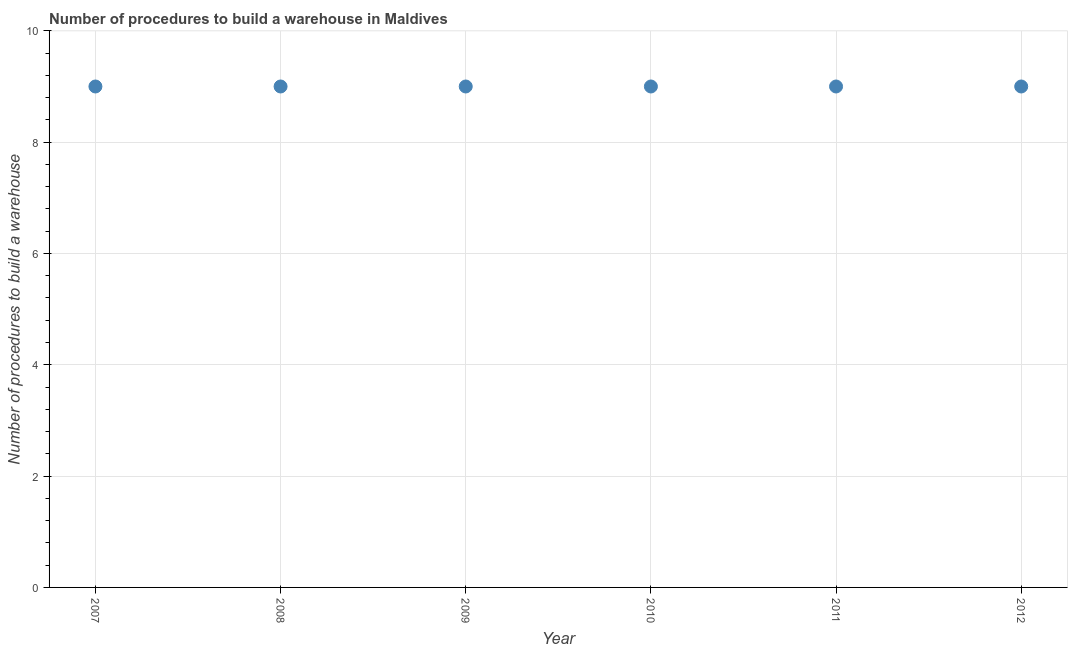What is the number of procedures to build a warehouse in 2008?
Provide a short and direct response. 9. Across all years, what is the maximum number of procedures to build a warehouse?
Offer a terse response. 9. Across all years, what is the minimum number of procedures to build a warehouse?
Your answer should be compact. 9. In which year was the number of procedures to build a warehouse maximum?
Provide a succinct answer. 2007. What is the sum of the number of procedures to build a warehouse?
Give a very brief answer. 54. What is the difference between the number of procedures to build a warehouse in 2007 and 2012?
Provide a short and direct response. 0. What is the average number of procedures to build a warehouse per year?
Offer a terse response. 9. What is the median number of procedures to build a warehouse?
Your answer should be compact. 9. In how many years, is the number of procedures to build a warehouse greater than 0.4 ?
Ensure brevity in your answer.  6. Do a majority of the years between 2010 and 2008 (inclusive) have number of procedures to build a warehouse greater than 4 ?
Make the answer very short. No. What is the ratio of the number of procedures to build a warehouse in 2007 to that in 2009?
Make the answer very short. 1. Is the number of procedures to build a warehouse in 2008 less than that in 2009?
Give a very brief answer. No. What is the difference between the highest and the second highest number of procedures to build a warehouse?
Provide a short and direct response. 0. Is the sum of the number of procedures to build a warehouse in 2007 and 2012 greater than the maximum number of procedures to build a warehouse across all years?
Offer a very short reply. Yes. What is the difference between the highest and the lowest number of procedures to build a warehouse?
Keep it short and to the point. 0. Does the number of procedures to build a warehouse monotonically increase over the years?
Keep it short and to the point. No. How many dotlines are there?
Provide a succinct answer. 1. Does the graph contain any zero values?
Offer a terse response. No. Does the graph contain grids?
Your response must be concise. Yes. What is the title of the graph?
Make the answer very short. Number of procedures to build a warehouse in Maldives. What is the label or title of the X-axis?
Keep it short and to the point. Year. What is the label or title of the Y-axis?
Your answer should be very brief. Number of procedures to build a warehouse. What is the Number of procedures to build a warehouse in 2007?
Provide a short and direct response. 9. What is the Number of procedures to build a warehouse in 2012?
Your answer should be very brief. 9. What is the difference between the Number of procedures to build a warehouse in 2007 and 2010?
Your answer should be compact. 0. What is the difference between the Number of procedures to build a warehouse in 2007 and 2011?
Provide a short and direct response. 0. What is the difference between the Number of procedures to build a warehouse in 2008 and 2009?
Your response must be concise. 0. What is the difference between the Number of procedures to build a warehouse in 2008 and 2010?
Ensure brevity in your answer.  0. What is the difference between the Number of procedures to build a warehouse in 2008 and 2011?
Ensure brevity in your answer.  0. What is the difference between the Number of procedures to build a warehouse in 2009 and 2010?
Provide a short and direct response. 0. What is the ratio of the Number of procedures to build a warehouse in 2007 to that in 2008?
Make the answer very short. 1. What is the ratio of the Number of procedures to build a warehouse in 2007 to that in 2009?
Ensure brevity in your answer.  1. What is the ratio of the Number of procedures to build a warehouse in 2007 to that in 2010?
Offer a very short reply. 1. What is the ratio of the Number of procedures to build a warehouse in 2007 to that in 2011?
Your answer should be compact. 1. What is the ratio of the Number of procedures to build a warehouse in 2008 to that in 2012?
Provide a short and direct response. 1. What is the ratio of the Number of procedures to build a warehouse in 2009 to that in 2010?
Provide a short and direct response. 1. What is the ratio of the Number of procedures to build a warehouse in 2010 to that in 2012?
Ensure brevity in your answer.  1. What is the ratio of the Number of procedures to build a warehouse in 2011 to that in 2012?
Keep it short and to the point. 1. 